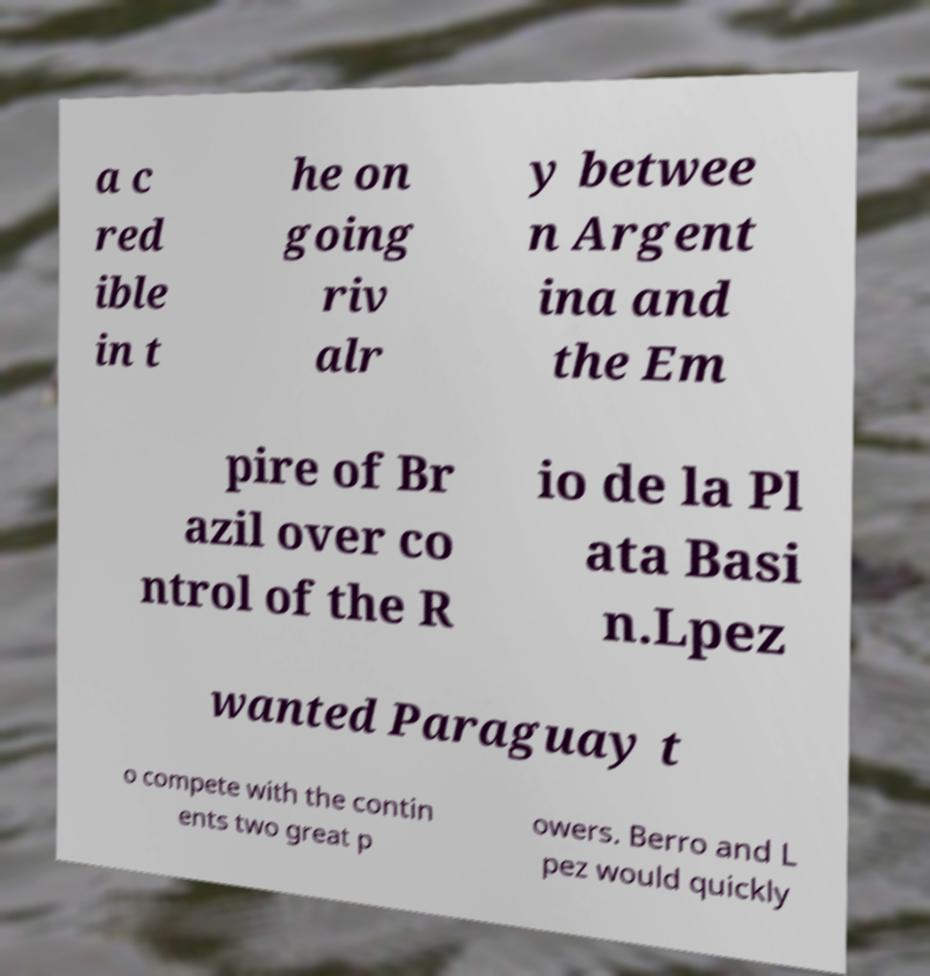Could you assist in decoding the text presented in this image and type it out clearly? a c red ible in t he on going riv alr y betwee n Argent ina and the Em pire of Br azil over co ntrol of the R io de la Pl ata Basi n.Lpez wanted Paraguay t o compete with the contin ents two great p owers. Berro and L pez would quickly 